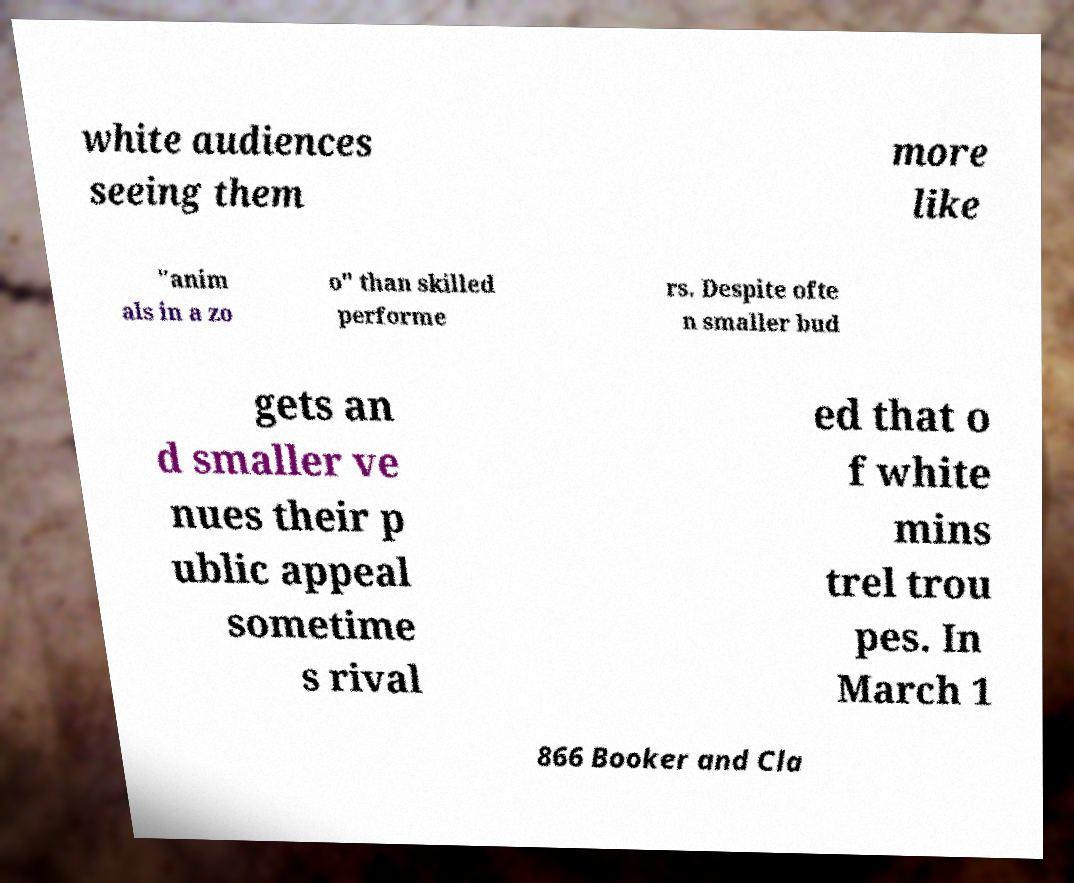There's text embedded in this image that I need extracted. Can you transcribe it verbatim? white audiences seeing them more like "anim als in a zo o" than skilled performe rs. Despite ofte n smaller bud gets an d smaller ve nues their p ublic appeal sometime s rival ed that o f white mins trel trou pes. In March 1 866 Booker and Cla 